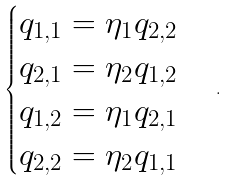Convert formula to latex. <formula><loc_0><loc_0><loc_500><loc_500>\begin{cases} q _ { 1 , 1 } = \eta _ { 1 } q _ { 2 , 2 } \\ q _ { 2 , 1 } = \eta _ { 2 } q _ { 1 , 2 } \\ q _ { 1 , 2 } = \eta _ { 1 } q _ { 2 , 1 } \\ q _ { 2 , 2 } = \eta _ { 2 } q _ { 1 , 1 } \end{cases} .</formula> 